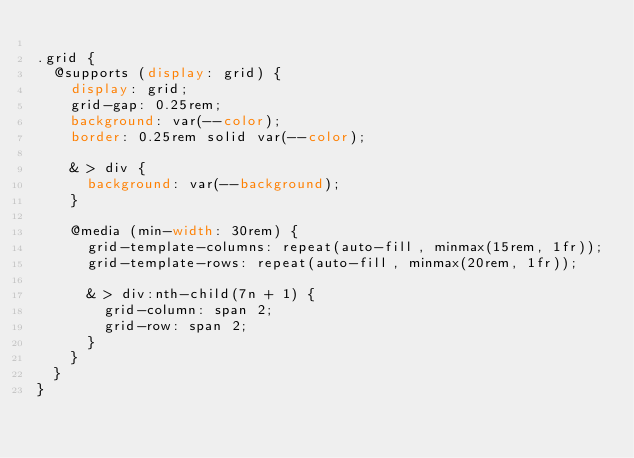<code> <loc_0><loc_0><loc_500><loc_500><_CSS_>
.grid {
  @supports (display: grid) {
    display: grid;
    grid-gap: 0.25rem;
    background: var(--color);
    border: 0.25rem solid var(--color);

    & > div {
      background: var(--background);
    }

    @media (min-width: 30rem) {
      grid-template-columns: repeat(auto-fill, minmax(15rem, 1fr));
      grid-template-rows: repeat(auto-fill, minmax(20rem, 1fr));

      & > div:nth-child(7n + 1) {
        grid-column: span 2;
        grid-row: span 2;
      }
    }
  }
}
</code> 